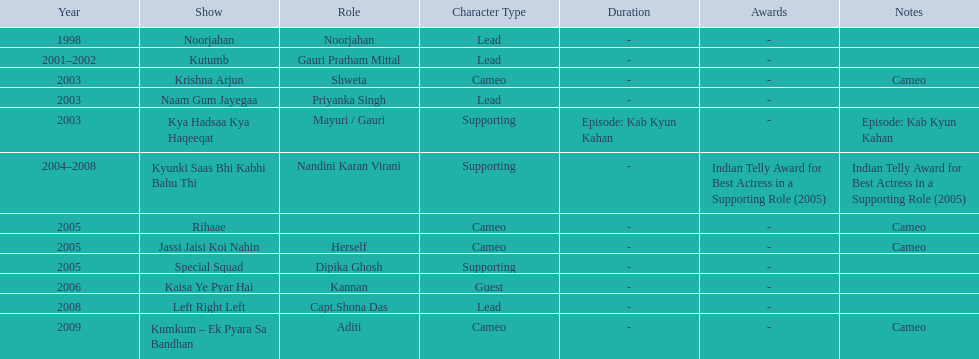What are all of the shows? Noorjahan, Kutumb, Krishna Arjun, Naam Gum Jayegaa, Kya Hadsaa Kya Haqeeqat, Kyunki Saas Bhi Kabhi Bahu Thi, Rihaae, Jassi Jaisi Koi Nahin, Special Squad, Kaisa Ye Pyar Hai, Left Right Left, Kumkum – Ek Pyara Sa Bandhan. When did they premiere? 1998, 2001–2002, 2003, 2003, 2003, 2004–2008, 2005, 2005, 2005, 2006, 2008, 2009. What notes are there for the shows from 2005? Cameo, Cameo. Along with rihaee, what is the other show gauri had a cameo role in? Jassi Jaisi Koi Nahin. 